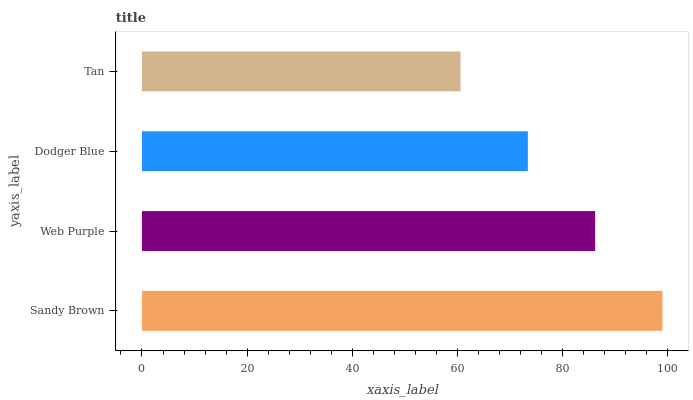Is Tan the minimum?
Answer yes or no. Yes. Is Sandy Brown the maximum?
Answer yes or no. Yes. Is Web Purple the minimum?
Answer yes or no. No. Is Web Purple the maximum?
Answer yes or no. No. Is Sandy Brown greater than Web Purple?
Answer yes or no. Yes. Is Web Purple less than Sandy Brown?
Answer yes or no. Yes. Is Web Purple greater than Sandy Brown?
Answer yes or no. No. Is Sandy Brown less than Web Purple?
Answer yes or no. No. Is Web Purple the high median?
Answer yes or no. Yes. Is Dodger Blue the low median?
Answer yes or no. Yes. Is Tan the high median?
Answer yes or no. No. Is Sandy Brown the low median?
Answer yes or no. No. 